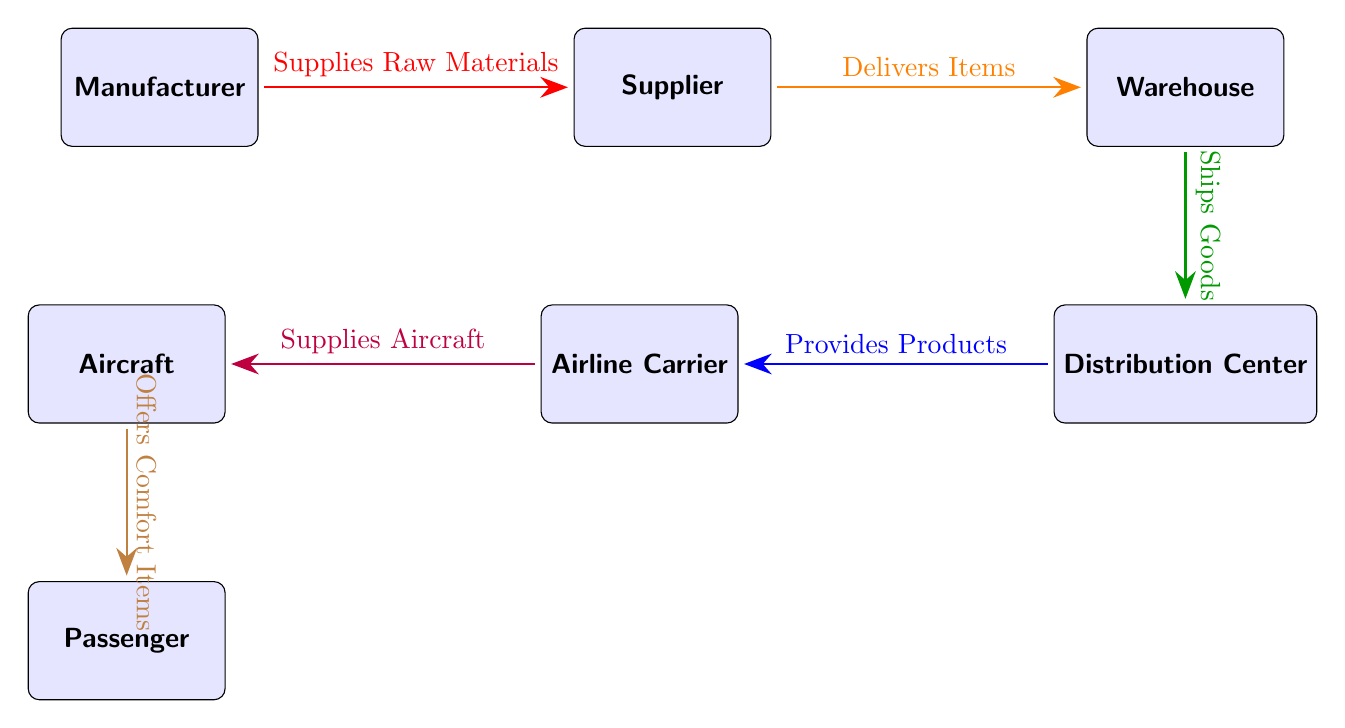What is the first node in the supply chain? The first node is identified as "Manufacturer" at the far left of the diagram, indicating it is the starting point of the supply chain.
Answer: Manufacturer How many nodes are present in the diagram? The diagram visually shows a total of six nodes, including the Manufacturer, Supplier, Warehouse, Distribution Center, Airline Carrier, and Aircraft.
Answer: Six What is the relationship between the Manufacturer and the Supplier? The arrow indicates that the Manufacturer "Supplies Raw Materials" to the Supplier, showing a direct relationship focused on material provision.
Answer: Supplies Raw Materials What does the Distribution Center provide? The arrow leading from the Distribution Center to the Airline Carrier specifies that it "Provides Products," indicating the role of the Distribution Center in supplying airline services.
Answer: Provides Products What is the final output of the supply chain? Following the flow from the Aircraft to the Passenger, the final output indicated is that the Aircraft "Offers Comfort Items" to the Passenger, highlighting the end result of the supply chain process.
Answer: Offers Comfort Items Which node is positioned directly below the Warehouse? The diagram places the Distribution Center directly below the Warehouse, illustrating the vertical relationship and sequence in the logistics process.
Answer: Distribution Center What type of goods are shipped from the Warehouse? The diagram indicates that the Warehouse "Ships Goods" to the Distribution Center, specifying the nature of items being handled in this segment.
Answer: Goods How does the Airline Carrier interact with the Aircraft? The arrow shows that the Airline Carrier "Supplies Aircraft," which means the Airline Carrier plays a role in equipping the aircraft with necessary items for service.
Answer: Supplies Aircraft What color is the arrow that represents goods being shipped from the Warehouse? The arrow that represents this action is depicted in green, which is a distinctive color used to show the flow of goods from Warehouse to Distribution Center.
Answer: Green 